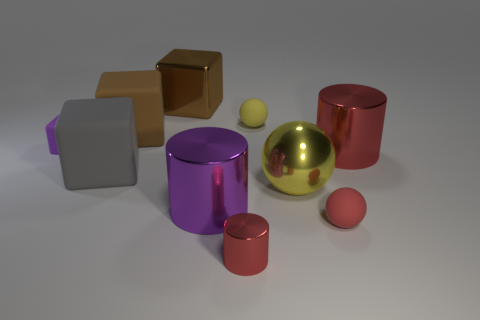Subtract all tiny metallic cylinders. How many cylinders are left? 2 Subtract all red balls. How many balls are left? 2 Subtract all blocks. How many objects are left? 6 Subtract 3 cylinders. How many cylinders are left? 0 Subtract all gray cylinders. How many brown balls are left? 0 Subtract 0 brown balls. How many objects are left? 10 Subtract all purple balls. Subtract all cyan cylinders. How many balls are left? 3 Subtract all purple rubber cubes. Subtract all big purple shiny cylinders. How many objects are left? 8 Add 1 large purple cylinders. How many large purple cylinders are left? 2 Add 3 yellow spheres. How many yellow spheres exist? 5 